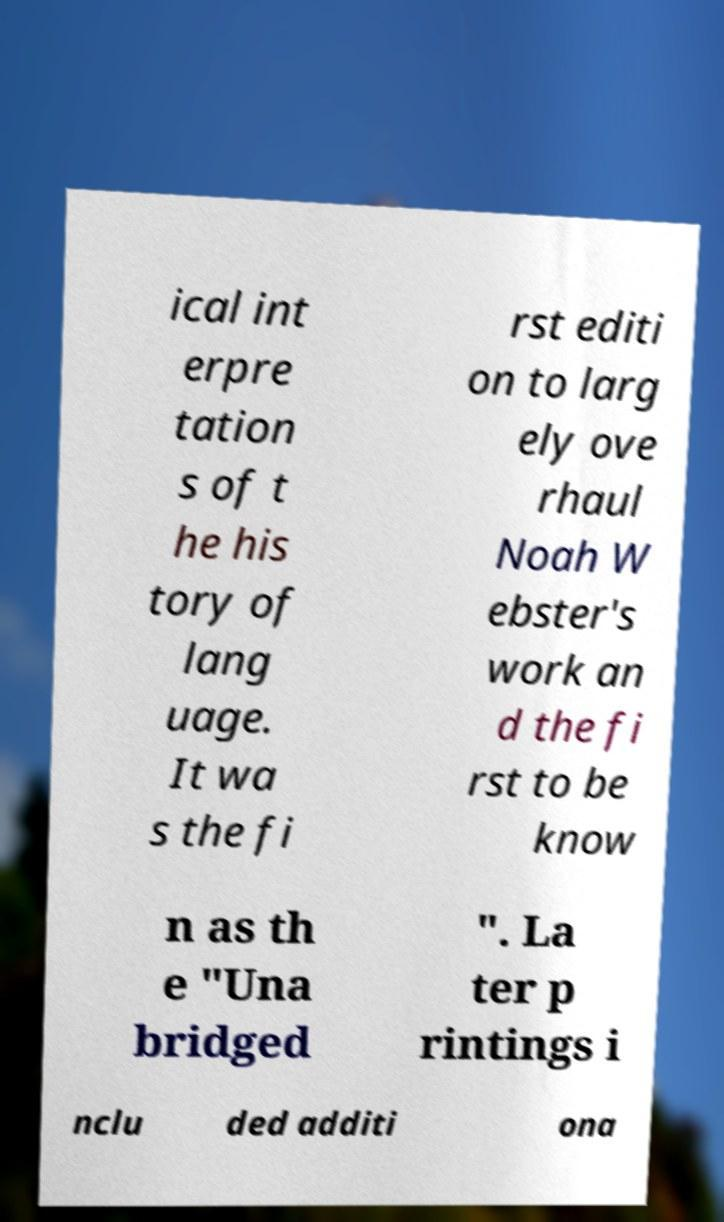Could you assist in decoding the text presented in this image and type it out clearly? ical int erpre tation s of t he his tory of lang uage. It wa s the fi rst editi on to larg ely ove rhaul Noah W ebster's work an d the fi rst to be know n as th e "Una bridged ". La ter p rintings i nclu ded additi ona 